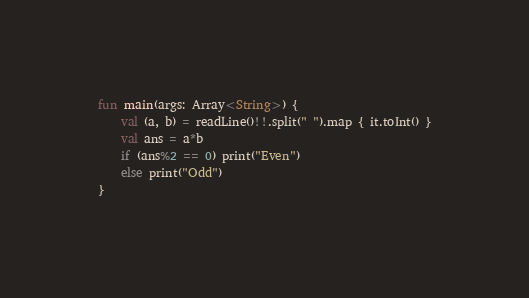Convert code to text. <code><loc_0><loc_0><loc_500><loc_500><_Kotlin_>fun main(args: Array<String>) {
    val (a, b) = readLine()!!.split(" ").map { it.toInt() }
    val ans = a*b
    if (ans%2 == 0) print("Even")
    else print("Odd")
}</code> 